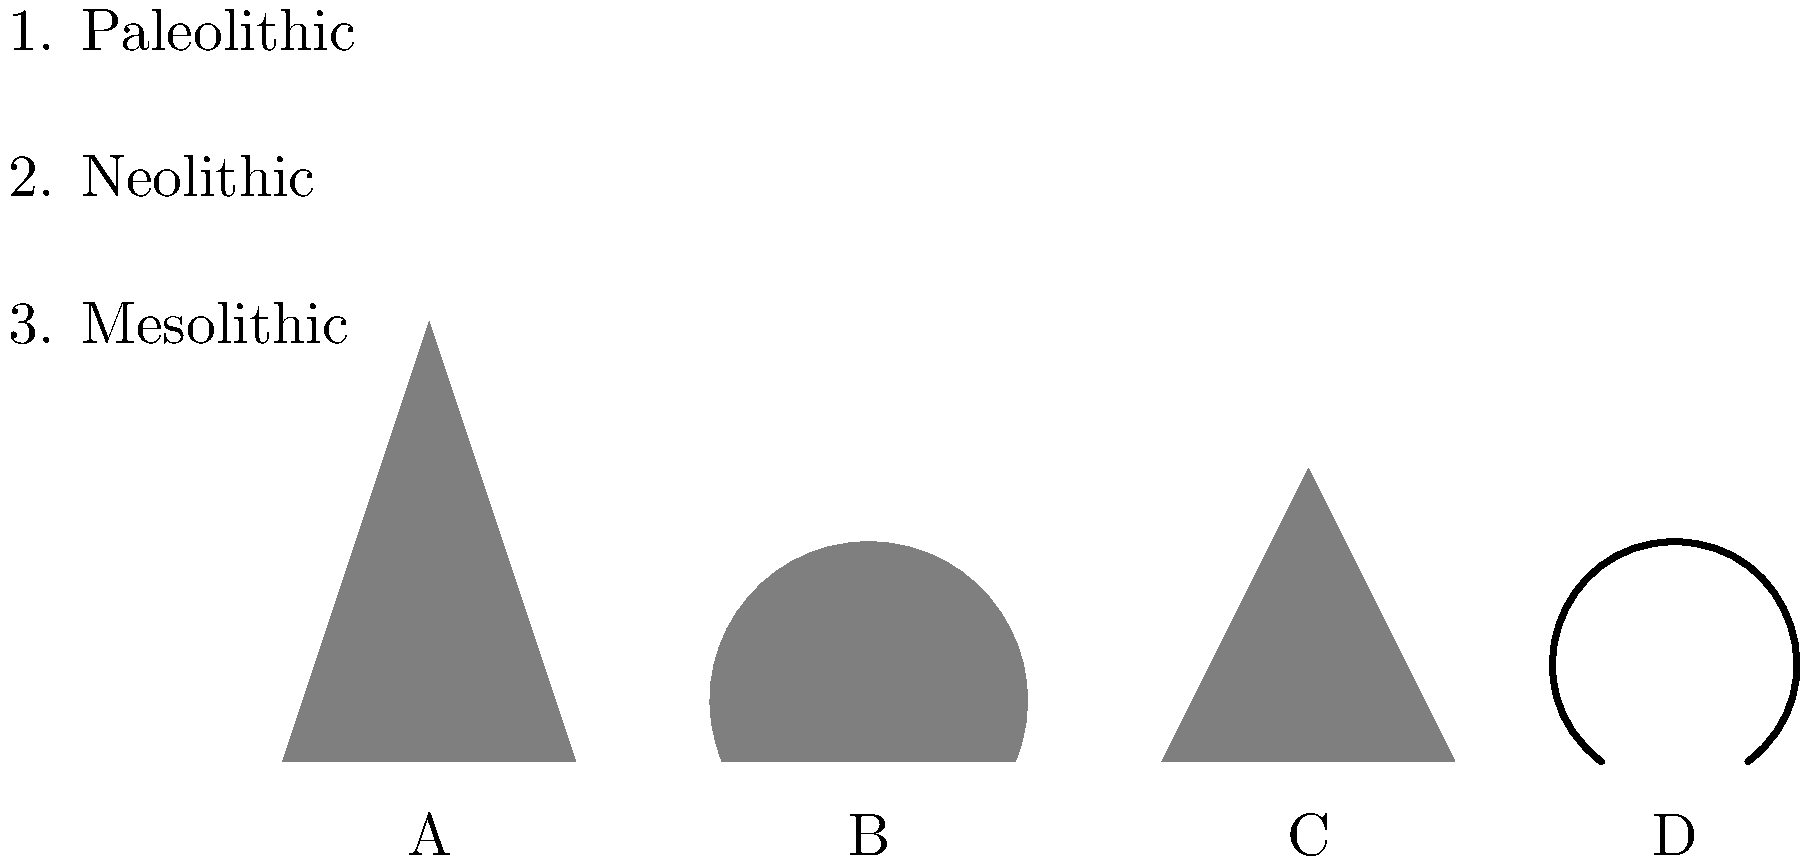Match the prehistoric tool silhouettes (A-D) with their corresponding time periods (1-3). Which tool belongs to the Paleolithic period? To answer this question, we need to analyze each tool silhouette and match it to the appropriate prehistoric time period:

1. Tool A: This is a spear point, typically associated with the Paleolithic period. Spear points were one of the earliest stone tools used by early humans for hunting large game.

2. Tool B: This appears to be a hand axe, also known as a biface. Hand axes are characteristic of the Paleolithic period, particularly the Lower and Middle Paleolithic.

3. Tool C: This silhouette represents an arrowhead, which is generally associated with the Mesolithic period. The invention of the bow and arrow marked a significant technological advancement in hunting techniques.

4. Tool D: This shape suggests a piece of pottery, which is a hallmark of the Neolithic period. The development of pottery is closely tied to the transition to agricultural societies.

Among these tools, the one that belongs to the Paleolithic period is the hand axe (Tool B). Hand axes were versatile tools used for various purposes, including cutting meat, working wood, and digging. They were produced and used over a long period during the Paleolithic, making them one of the most iconic tools of this era.
Answer: B (Hand axe) 